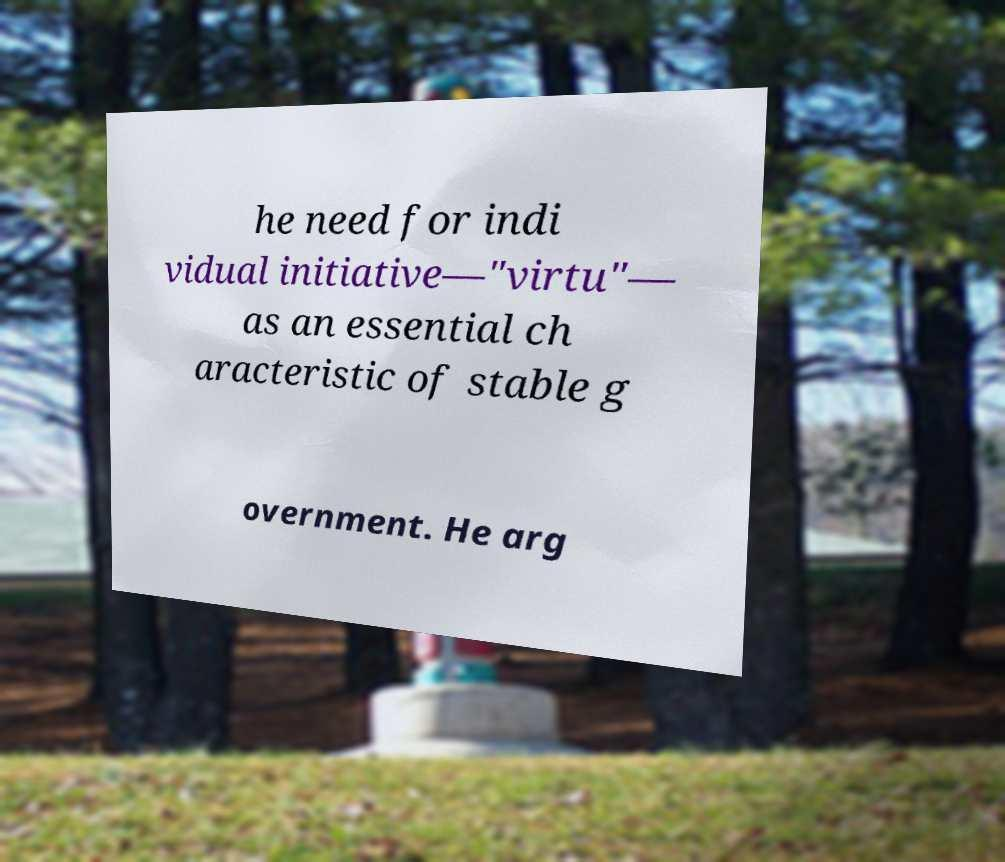Can you read and provide the text displayed in the image?This photo seems to have some interesting text. Can you extract and type it out for me? he need for indi vidual initiative—"virtu"— as an essential ch aracteristic of stable g overnment. He arg 